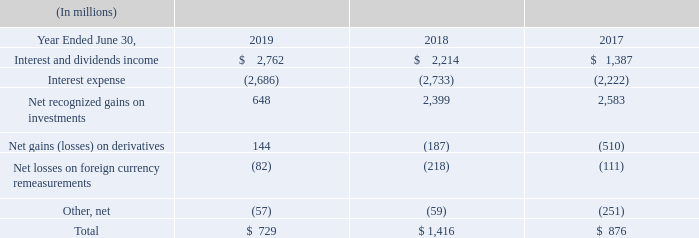OTHER INCOME (EXPENSE), NET
The components of other income (expense), net were as follows:
We use derivative instruments to: manage risks related to foreign currencies, equity prices, interest rates, and credit; enhance investment returns; and facilitate portfolio diversification. Gains and losses from changes in fair values of derivatives that are not designated as hedging instruments are primarily recognized in other income (expense), net.
Fiscal Year 2019 Compared with Fiscal Year 2018 Interest and dividends income increased primarily due to higher yields on fixed-income securities. Interest expense decreased primarily driven by a decrease in outstanding long-term debt due to debt maturities, offset in part by higher finance lease expense. Net recognized gains on investments decreased primarily due to lower gains on sales of equity investments. Net gains on derivatives includes gains on foreign exchange and interest rate derivatives in the current period as compared to losses in the prior period.
Fiscal Year 2018 Compared with Fiscal Year 2017 Dividends and interest income increased primarily due to higher average portfolio balances and yields on fixed-income securities. Interest expense increased primarily due to higher average outstanding long-term debt and higher finance lease expense. Net recognized gains on investments decreased primarily due to higher losses on sales of fixed-income securities, offset in part by higher gains on sales of equity securities. Net losses on derivatives decreased primarily due to lower losses on equity, foreign exchange, and commodity derivatives, offset in part by losses on interest rate derivatives in the current period as compared to gains in the prior period.
What does the company use derivative instruments for? Manage risks related to foreign currencies, equity prices, interest rates, and credit; enhance investment returns; and facilitate portfolio diversification. Why did interest and dividends income change from 2018 to 2019? Interest and dividends income increased primarily due to higher yields on fixed-income securities. Why did interest and dividends income increase from $1,387 million in 2017 to $2,214 million in 2018? Dividends and interest income increased primarily due to higher average portfolio balances and yields on fixed-income securities. What is the average interest and dividend income for the 3 year period from 2017 to 2019?
Answer scale should be: million. (2,762+2,214+1,387)/3
Answer: 2121. What is the average total income from 2017 to 2019?
Answer scale should be: million. (729+1,416+876)/3
Answer: 1007. What was the % change in interest and dividends income from 2018 to 2019?
Answer scale should be: percent. (2,762-2,214)/2,214
Answer: 24.75. 